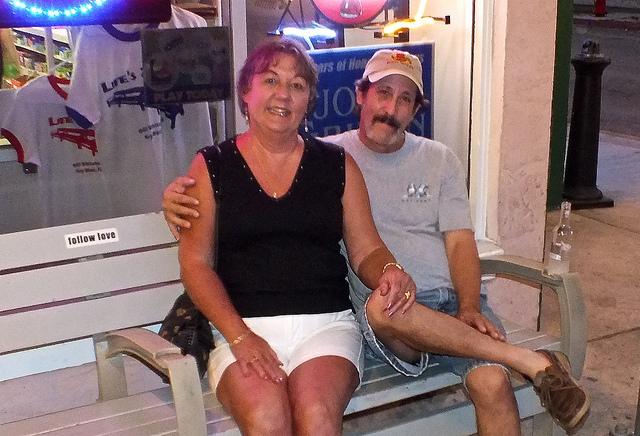What are they sitting on?
Give a very brief answer. Bench. What does it say on the beach photo?
Concise answer only. Follow love. How many people are sitting?
Write a very short answer. 2. What does the bench say?
Quick response, please. Follow love. Are they a couple?
Give a very brief answer. Yes. 